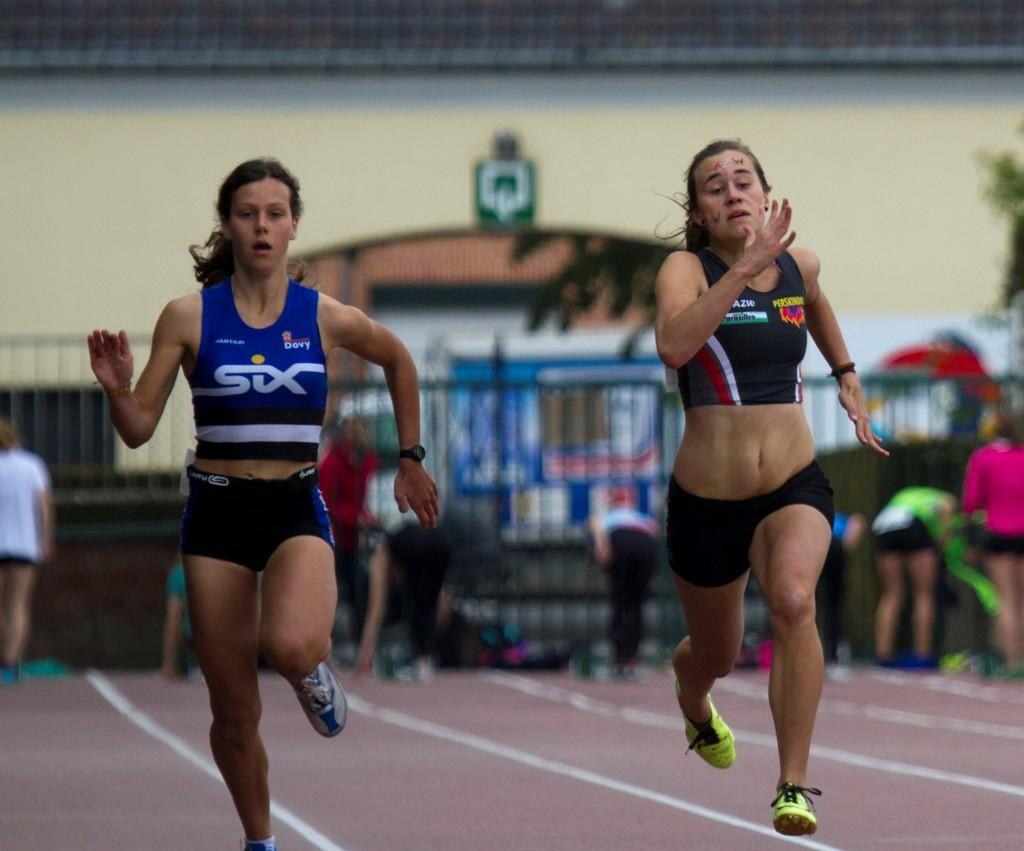Provide a one-sentence caption for the provided image. Two runners are racing on a track, the one on the left wearing a Six top. 